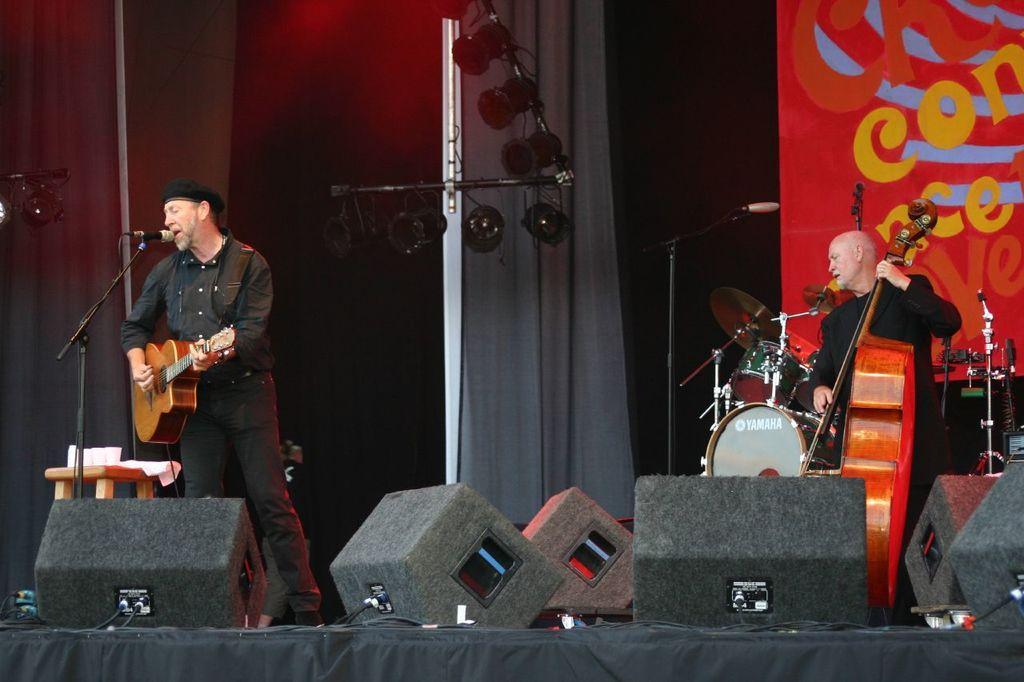Please provide a concise description of this image. Here we can see the person on the left side playing a guitar and singing a song with microphone in front of him and the person on the right side is playing violin, there are other musical instruments present and there are speakers also present here and there, there is a banner present 